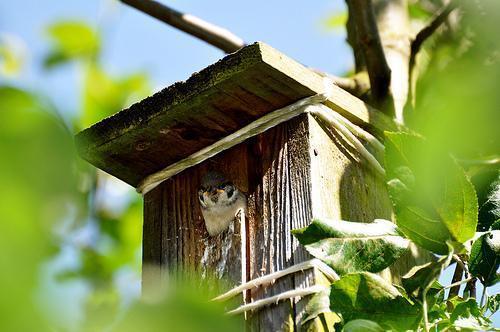How many birds are shown?
Give a very brief answer. 1. 